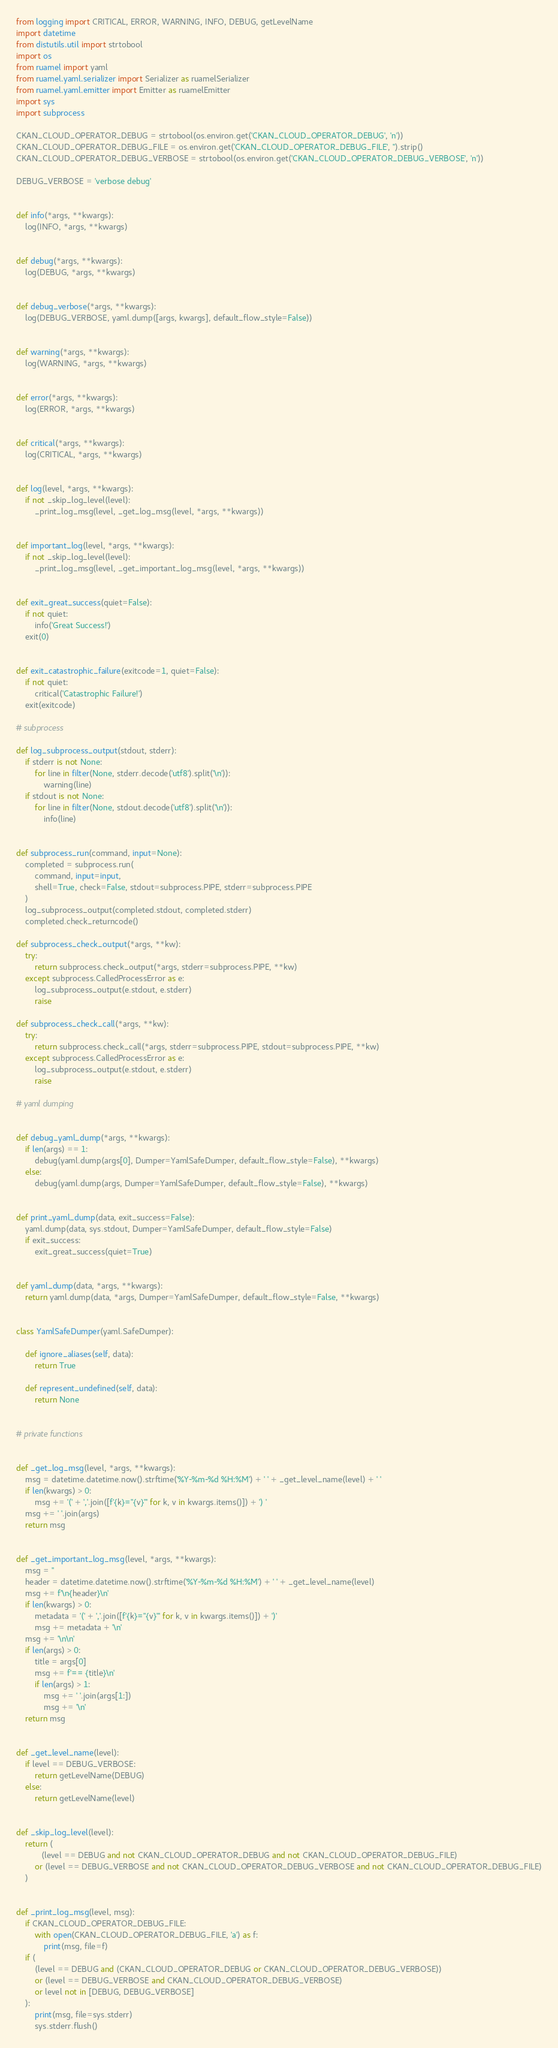<code> <loc_0><loc_0><loc_500><loc_500><_Python_>from logging import CRITICAL, ERROR, WARNING, INFO, DEBUG, getLevelName
import datetime
from distutils.util import strtobool
import os
from ruamel import yaml
from ruamel.yaml.serializer import Serializer as ruamelSerializer
from ruamel.yaml.emitter import Emitter as ruamelEmitter
import sys
import subprocess

CKAN_CLOUD_OPERATOR_DEBUG = strtobool(os.environ.get('CKAN_CLOUD_OPERATOR_DEBUG', 'n'))
CKAN_CLOUD_OPERATOR_DEBUG_FILE = os.environ.get('CKAN_CLOUD_OPERATOR_DEBUG_FILE', '').strip()
CKAN_CLOUD_OPERATOR_DEBUG_VERBOSE = strtobool(os.environ.get('CKAN_CLOUD_OPERATOR_DEBUG_VERBOSE', 'n'))

DEBUG_VERBOSE = 'verbose debug'


def info(*args, **kwargs):
    log(INFO, *args, **kwargs)


def debug(*args, **kwargs):
    log(DEBUG, *args, **kwargs)


def debug_verbose(*args, **kwargs):
    log(DEBUG_VERBOSE, yaml.dump([args, kwargs], default_flow_style=False))


def warning(*args, **kwargs):
    log(WARNING, *args, **kwargs)


def error(*args, **kwargs):
    log(ERROR, *args, **kwargs)


def critical(*args, **kwargs):
    log(CRITICAL, *args, **kwargs)


def log(level, *args, **kwargs):
    if not _skip_log_level(level):
        _print_log_msg(level, _get_log_msg(level, *args, **kwargs))


def important_log(level, *args, **kwargs):
    if not _skip_log_level(level):
        _print_log_msg(level, _get_important_log_msg(level, *args, **kwargs))


def exit_great_success(quiet=False):
    if not quiet:
        info('Great Success!')
    exit(0)


def exit_catastrophic_failure(exitcode=1, quiet=False):
    if not quiet:
        critical('Catastrophic Failure!')
    exit(exitcode)

# subprocess

def log_subprocess_output(stdout, stderr):
    if stderr is not None:
        for line in filter(None, stderr.decode('utf8').split('\n')):
            warning(line)
    if stdout is not None:
        for line in filter(None, stdout.decode('utf8').split('\n')):
            info(line)


def subprocess_run(command, input=None):
    completed = subprocess.run(
        command, input=input, 
        shell=True, check=False, stdout=subprocess.PIPE, stderr=subprocess.PIPE
    )
    log_subprocess_output(completed.stdout, completed.stderr)
    completed.check_returncode()

def subprocess_check_output(*args, **kw):
    try:
        return subprocess.check_output(*args, stderr=subprocess.PIPE, **kw)
    except subprocess.CalledProcessError as e:
        log_subprocess_output(e.stdout, e.stderr)
        raise

def subprocess_check_call(*args, **kw):
    try:
        return subprocess.check_call(*args, stderr=subprocess.PIPE, stdout=subprocess.PIPE, **kw)
    except subprocess.CalledProcessError as e:
        log_subprocess_output(e.stdout, e.stderr)
        raise

# yaml dumping


def debug_yaml_dump(*args, **kwargs):
    if len(args) == 1:
        debug(yaml.dump(args[0], Dumper=YamlSafeDumper, default_flow_style=False), **kwargs)
    else:
        debug(yaml.dump(args, Dumper=YamlSafeDumper, default_flow_style=False), **kwargs)


def print_yaml_dump(data, exit_success=False):
    yaml.dump(data, sys.stdout, Dumper=YamlSafeDumper, default_flow_style=False)
    if exit_success:
        exit_great_success(quiet=True)


def yaml_dump(data, *args, **kwargs):
    return yaml.dump(data, *args, Dumper=YamlSafeDumper, default_flow_style=False, **kwargs)


class YamlSafeDumper(yaml.SafeDumper):

    def ignore_aliases(self, data):
        return True

    def represent_undefined(self, data):
        return None


# private functions


def _get_log_msg(level, *args, **kwargs):
    msg = datetime.datetime.now().strftime('%Y-%m-%d %H:%M') + ' ' + _get_level_name(level) + ' '
    if len(kwargs) > 0:
        msg += '(' + ','.join([f'{k}="{v}"' for k, v in kwargs.items()]) + ') '
    msg += ' '.join(args)
    return msg


def _get_important_log_msg(level, *args, **kwargs):
    msg = ''
    header = datetime.datetime.now().strftime('%Y-%m-%d %H:%M') + ' ' + _get_level_name(level)
    msg += f'\n{header}\n'
    if len(kwargs) > 0:
        metadata = '(' + ','.join([f'{k}="{v}"' for k, v in kwargs.items()]) + ')'
        msg += metadata + '\n'
    msg += '\n\n'
    if len(args) > 0:
        title = args[0]
        msg += f'== {title}\n'
        if len(args) > 1:
            msg += ' '.join(args[1:])
            msg += '\n'
    return msg


def _get_level_name(level):
    if level == DEBUG_VERBOSE:
        return getLevelName(DEBUG)
    else:
        return getLevelName(level)


def _skip_log_level(level):
    return (
           (level == DEBUG and not CKAN_CLOUD_OPERATOR_DEBUG and not CKAN_CLOUD_OPERATOR_DEBUG_FILE)
        or (level == DEBUG_VERBOSE and not CKAN_CLOUD_OPERATOR_DEBUG_VERBOSE and not CKAN_CLOUD_OPERATOR_DEBUG_FILE)
    )


def _print_log_msg(level, msg):
    if CKAN_CLOUD_OPERATOR_DEBUG_FILE:
        with open(CKAN_CLOUD_OPERATOR_DEBUG_FILE, 'a') as f:
            print(msg, file=f)
    if (
        (level == DEBUG and (CKAN_CLOUD_OPERATOR_DEBUG or CKAN_CLOUD_OPERATOR_DEBUG_VERBOSE))
        or (level == DEBUG_VERBOSE and CKAN_CLOUD_OPERATOR_DEBUG_VERBOSE)
        or level not in [DEBUG, DEBUG_VERBOSE]
    ):
        print(msg, file=sys.stderr)
        sys.stderr.flush()
</code> 